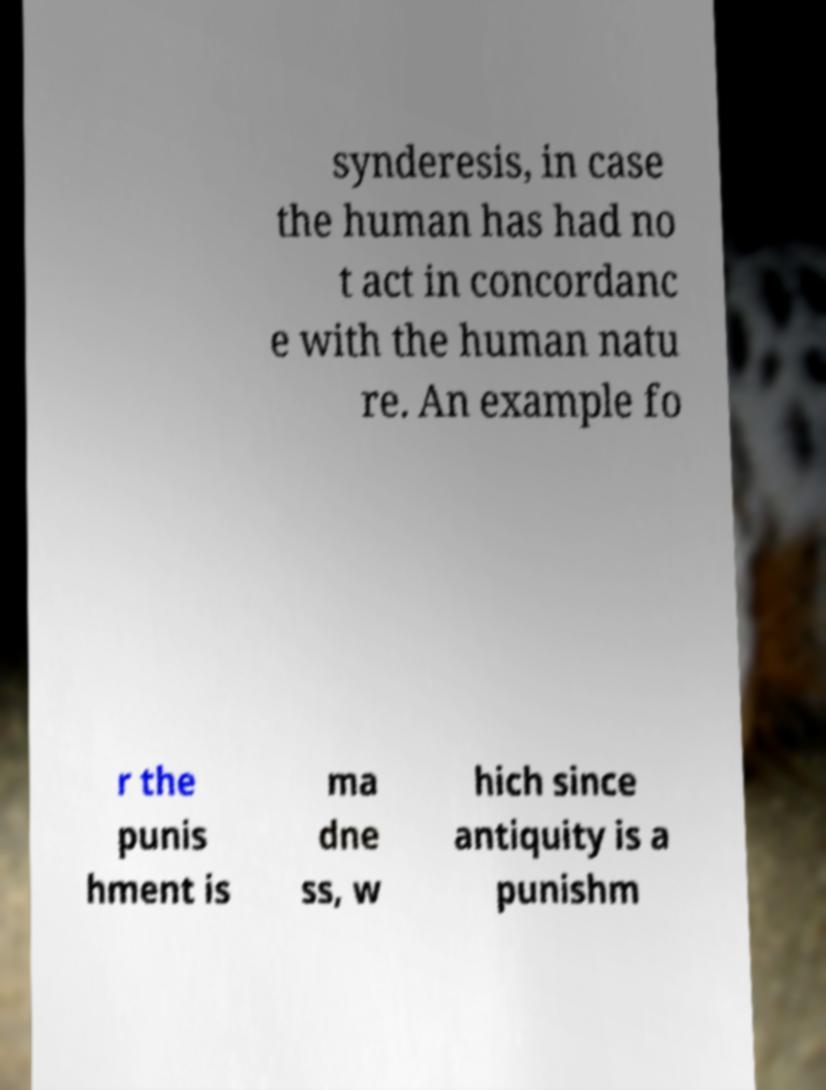There's text embedded in this image that I need extracted. Can you transcribe it verbatim? synderesis, in case the human has had no t act in concordanc e with the human natu re. An example fo r the punis hment is ma dne ss, w hich since antiquity is a punishm 